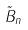Convert formula to latex. <formula><loc_0><loc_0><loc_500><loc_500>\tilde { B } _ { n }</formula> 